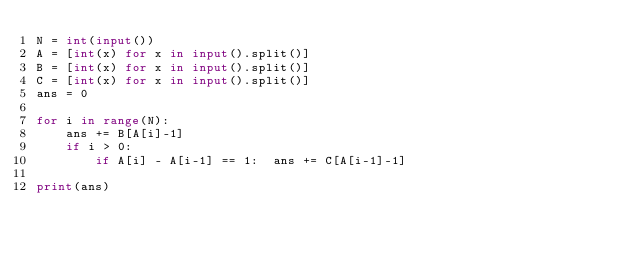<code> <loc_0><loc_0><loc_500><loc_500><_Python_>N = int(input())
A = [int(x) for x in input().split()]
B = [int(x) for x in input().split()]
C = [int(x) for x in input().split()]
ans = 0

for i in range(N):
    ans += B[A[i]-1]
    if i > 0:
        if A[i] - A[i-1] == 1:  ans += C[A[i-1]-1]

print(ans)</code> 